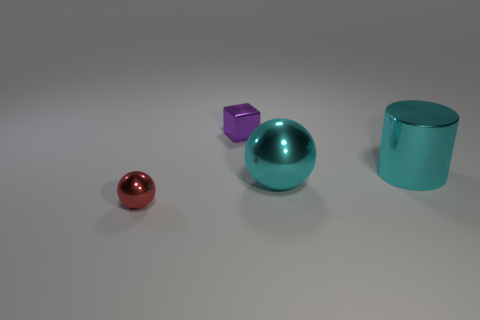How do the objects in the image relate to each other in terms of size? In the image, there's a noticeable hierarchy in the sizes of the objects. The small, red sphere seems to be the smallest, followed by the purple cube, which is larger but still noticeably smaller than the large cyan ball and teal cylinder. This gradation in size from smallest to largest creates a sense of depth and could represent a scale or progression. 